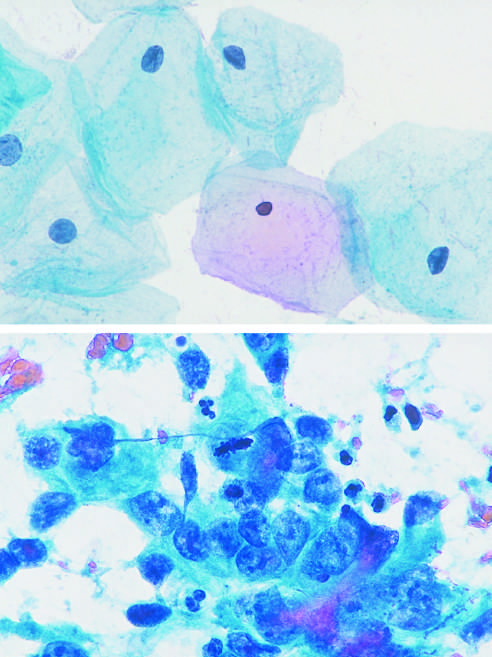re numerous friable mural thrombi in mitosis?
Answer the question using a single word or phrase. No 